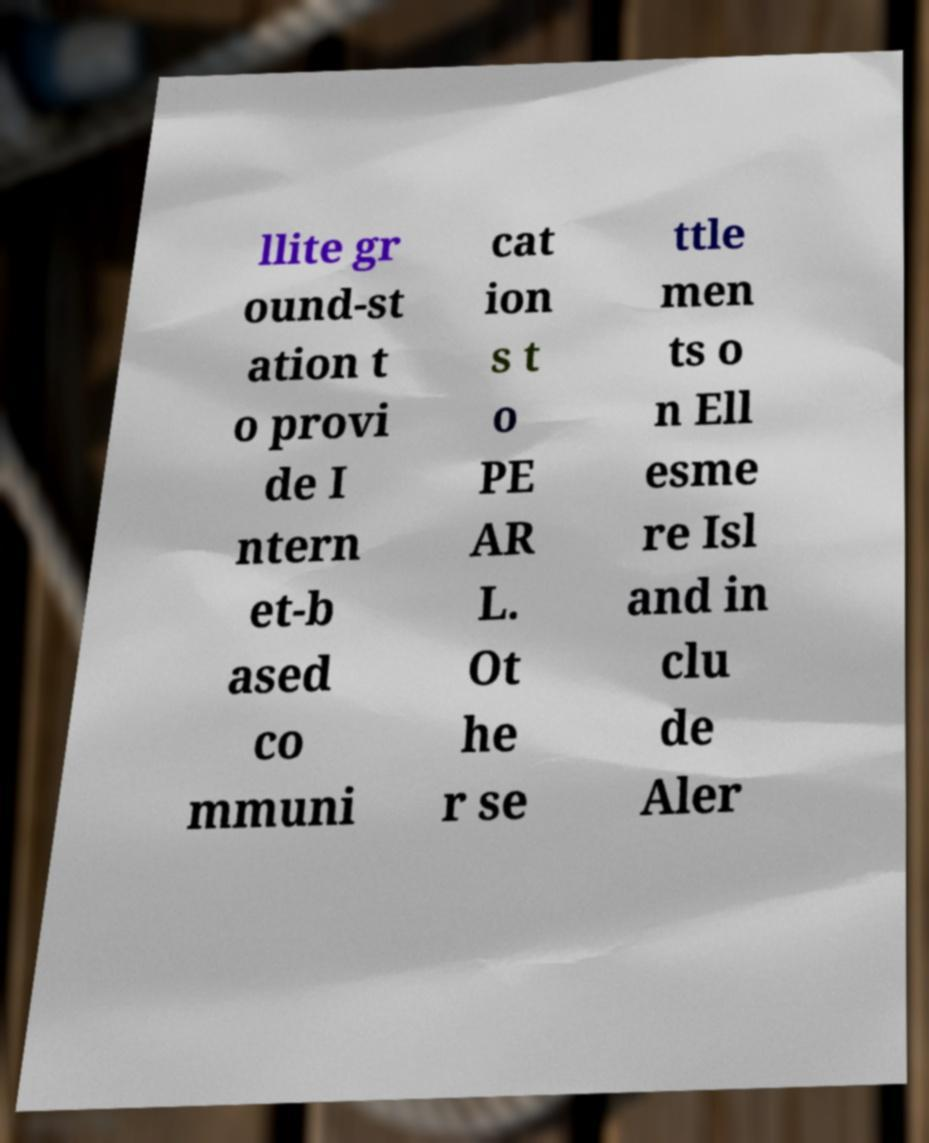Could you assist in decoding the text presented in this image and type it out clearly? llite gr ound-st ation t o provi de I ntern et-b ased co mmuni cat ion s t o PE AR L. Ot he r se ttle men ts o n Ell esme re Isl and in clu de Aler 